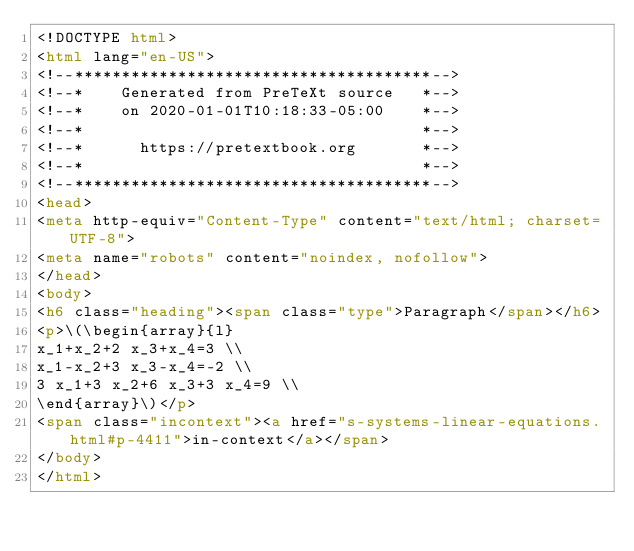<code> <loc_0><loc_0><loc_500><loc_500><_HTML_><!DOCTYPE html>
<html lang="en-US">
<!--**************************************-->
<!--*    Generated from PreTeXt source   *-->
<!--*    on 2020-01-01T10:18:33-05:00    *-->
<!--*                                    *-->
<!--*      https://pretextbook.org       *-->
<!--*                                    *-->
<!--**************************************-->
<head>
<meta http-equiv="Content-Type" content="text/html; charset=UTF-8">
<meta name="robots" content="noindex, nofollow">
</head>
<body>
<h6 class="heading"><span class="type">Paragraph</span></h6>
<p>\(\begin{array}{l}
x_1+x_2+2 x_3+x_4=3 \\
x_1-x_2+3 x_3-x_4=-2 \\
3 x_1+3 x_2+6 x_3+3 x_4=9 \\
\end{array}\)</p>
<span class="incontext"><a href="s-systems-linear-equations.html#p-4411">in-context</a></span>
</body>
</html>
</code> 